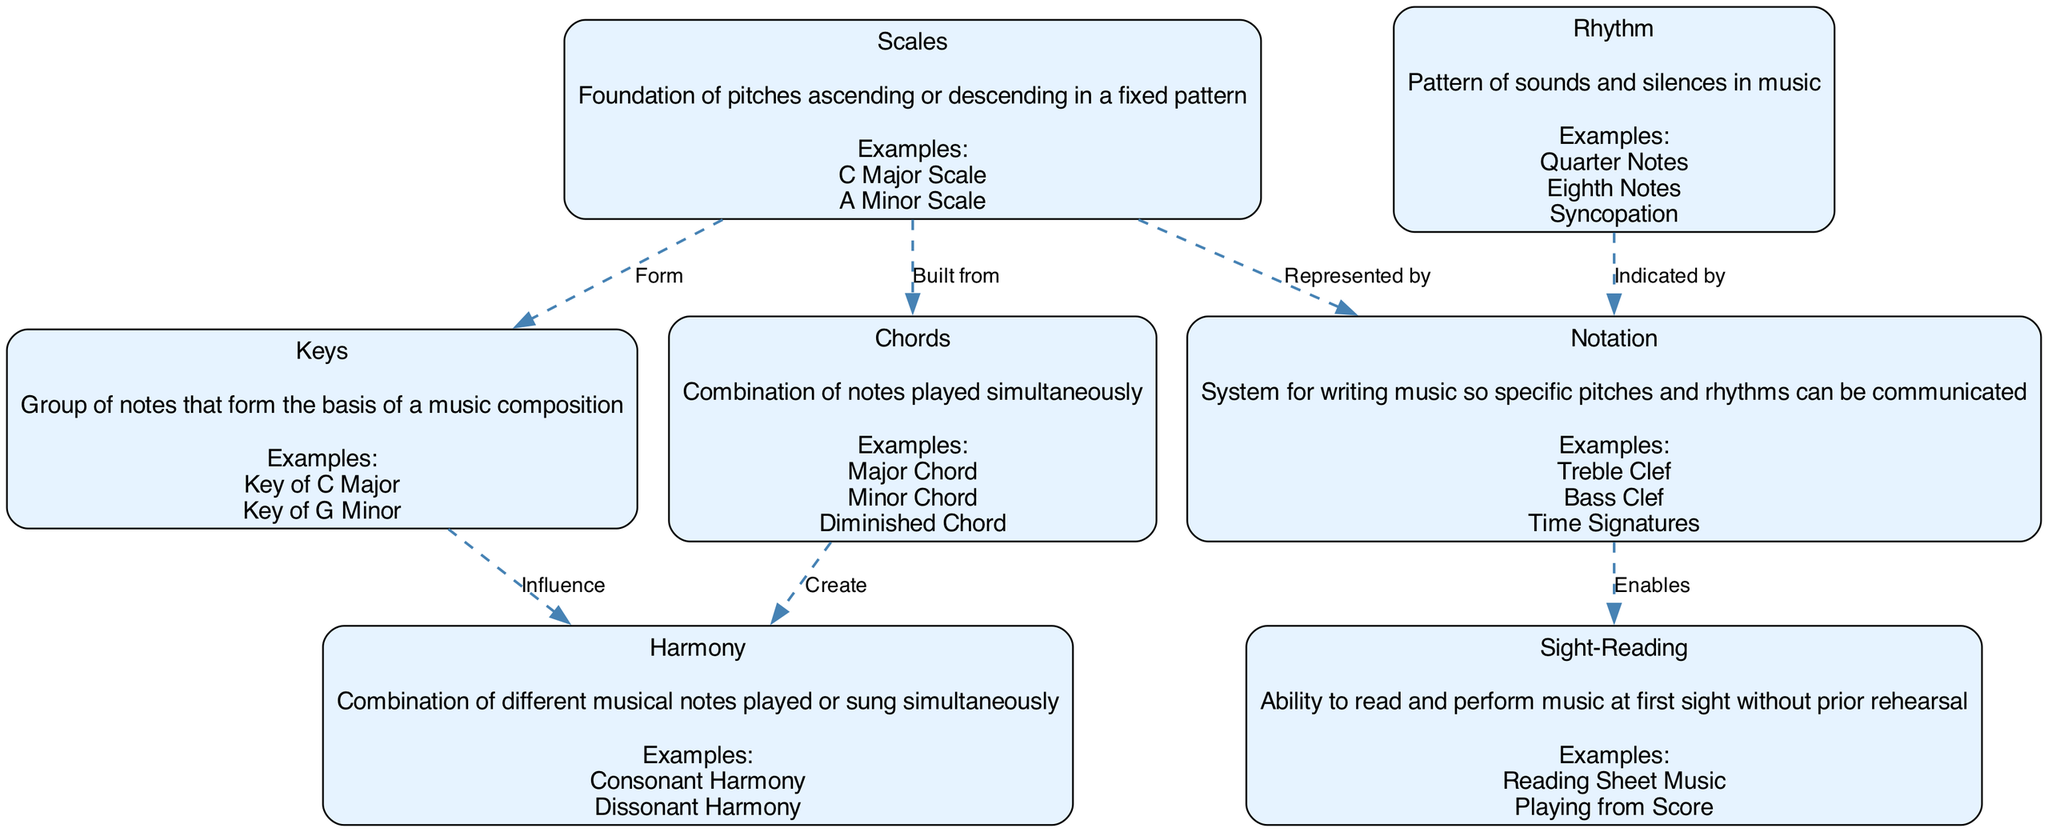What is the foundation of pitches in classical music? The node labeled "Scales" defines the foundation of pitches that are arranged in an ascending or descending order. This is the primary concept related to the given question.
Answer: Scales Which chord type is mentioned as a combination of notes played simultaneously? According to the node labeled "Chords," it specifies that chords are combinations of notes played at the same time, which is the basic information needed for the answer.
Answer: Chords How many nodes are there in the diagram? By counting the entries under the "nodes" section, we find there are a total of seven nodes listed. Thus, the number of nodes is derived from this count.
Answer: 7 What does rhythm indicate in classical music notation? The diagram indicates that the node "Rhythm" is connected to the "Notation" node through the relationship "Indicated by," which clarifies that rhythm is represented in notation.
Answer: Indicated by From which element are chords built? The diagram shows an edge labeled "Built from" that connects the "Scales" node to the "Chords" node, indicating that chords are constructed based on scales.
Answer: Scales Which element influences harmony in a music composition? The diagram connects the "Keys" node to the "Harmony" node with the label "Influence," indicating that keys play a significant role in shaping harmony in classical music.
Answer: Keys What does the notation enable according to the diagram? The edge labeled "Enables" connecting "Notation" to "Sight-Reading" shows that notation is crucial for the sight-reading ability of musicians. Thus, sight-reading ability is directly enabled by notation.
Answer: Sight-Reading What represents scales in music notation? The relationship defined as "Represented by" connects "Scales" to "Notation," which indicates that scales are depicted or represented in music notation.
Answer: Notation Which harmony type is created from chords? The diagram connects the "Chords" node to the "Harmony" node with the label "Create," establishing that harmony is developed through the use of chords.
Answer: Harmony 